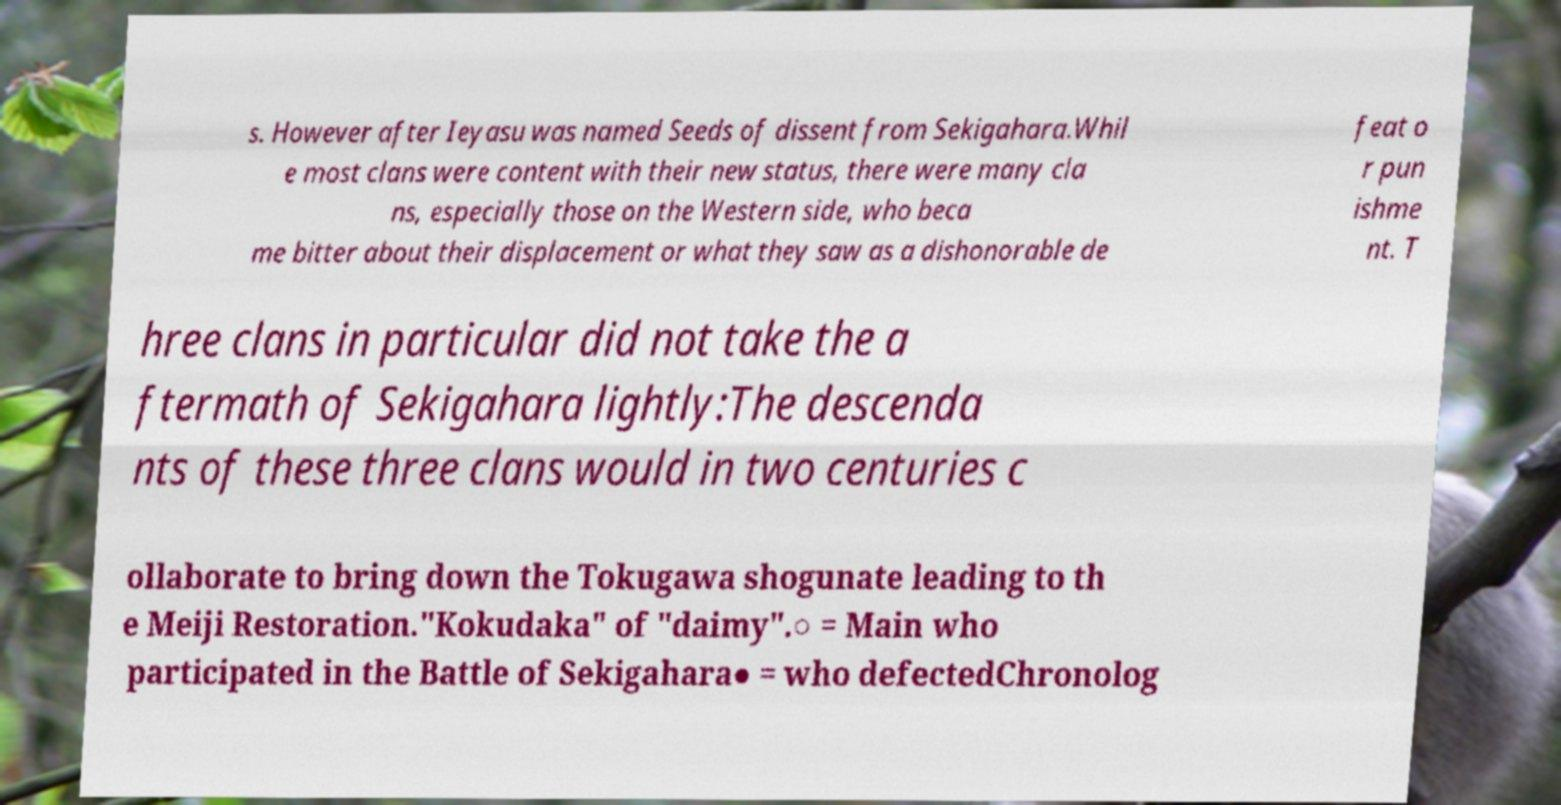I need the written content from this picture converted into text. Can you do that? s. However after Ieyasu was named Seeds of dissent from Sekigahara.Whil e most clans were content with their new status, there were many cla ns, especially those on the Western side, who beca me bitter about their displacement or what they saw as a dishonorable de feat o r pun ishme nt. T hree clans in particular did not take the a ftermath of Sekigahara lightly:The descenda nts of these three clans would in two centuries c ollaborate to bring down the Tokugawa shogunate leading to th e Meiji Restoration."Kokudaka" of "daimy".○ = Main who participated in the Battle of Sekigahara● = who defectedChronolog 